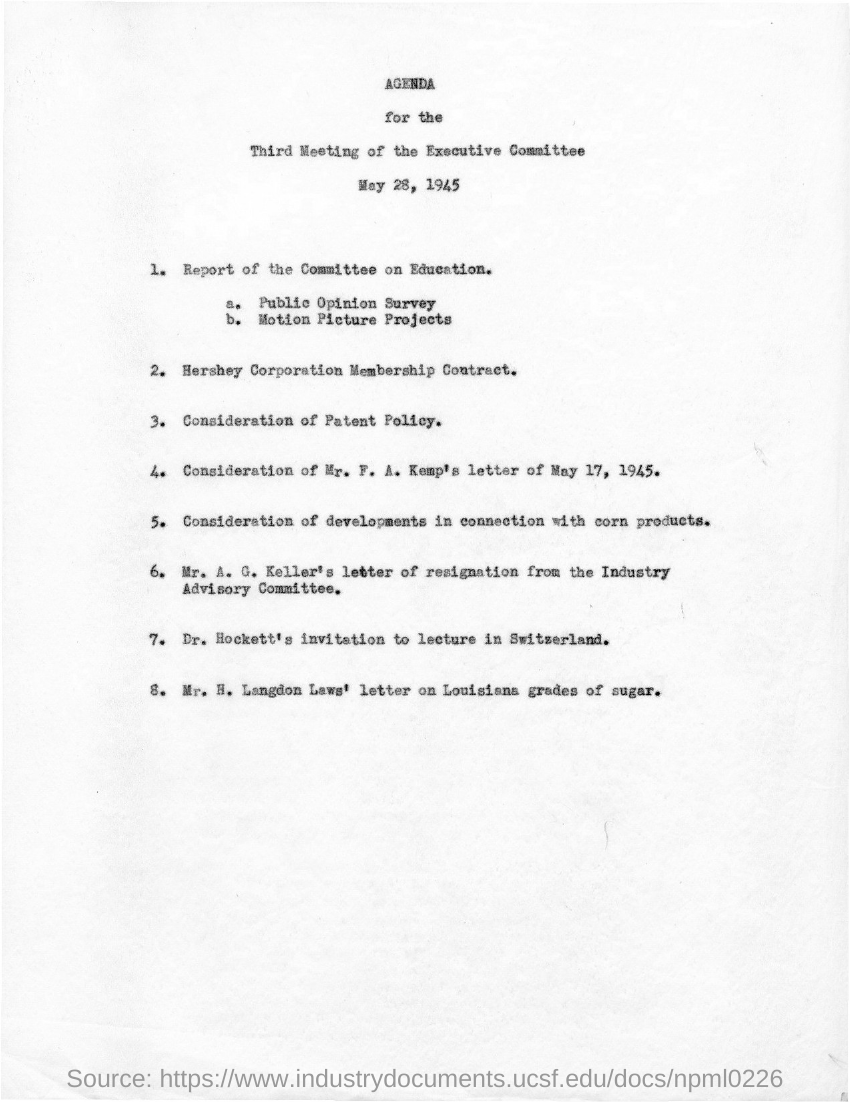Highlight a few significant elements in this photo. The document in question is titled 'Agenda for the third meeting of the executive committee.' 